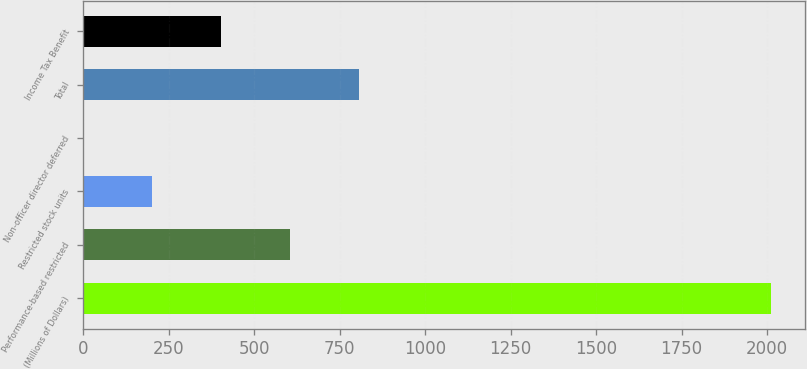Convert chart. <chart><loc_0><loc_0><loc_500><loc_500><bar_chart><fcel>(Millions of Dollars)<fcel>Performance-based restricted<fcel>Restricted stock units<fcel>Non-officer director deferred<fcel>Total<fcel>Income Tax Benefit<nl><fcel>2011<fcel>604<fcel>202<fcel>1<fcel>805<fcel>403<nl></chart> 